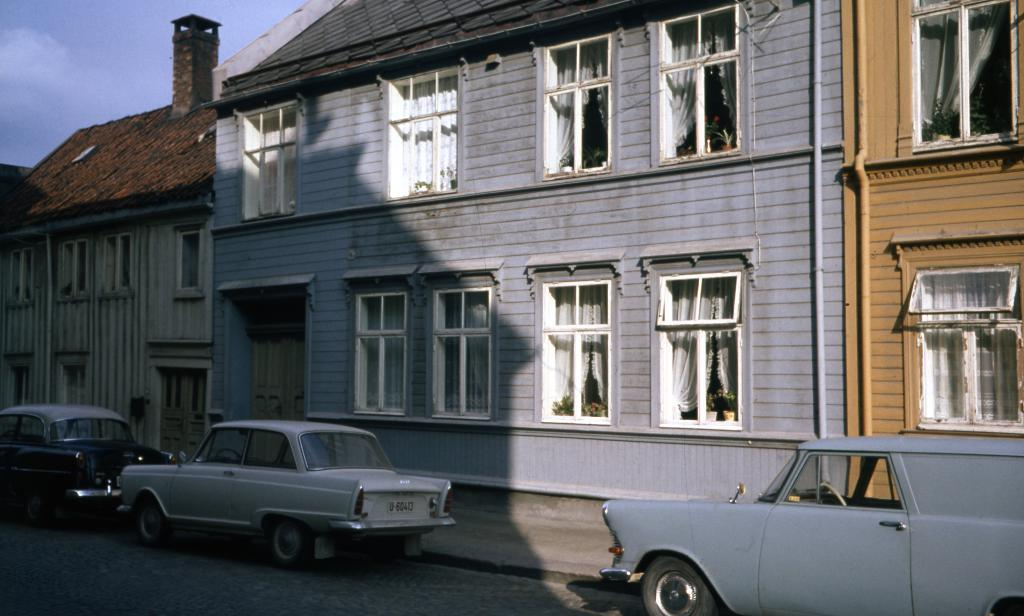What can be seen in the center of the image? There are cars on the road in the center of the image. What is visible in the background of the image? There are buildings in the background of the image. What color are the windows visible in the image? The windows visible in the image are white. How would you describe the sky in the image? The sky is cloudy in the image. What is the name of the horse in the image? There are no horses present in the image. What is the chance of winning a prize in the image? There is no indication of a prize or any game of chance in the image. 